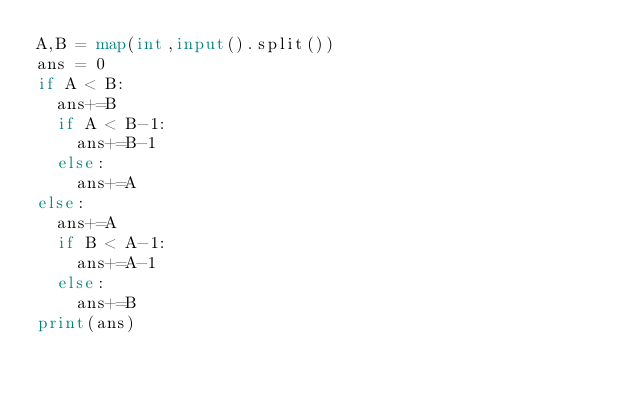Convert code to text. <code><loc_0><loc_0><loc_500><loc_500><_Python_>A,B = map(int,input().split())
ans = 0
if A < B:
  ans+=B
  if A < B-1:
    ans+=B-1
  else:
    ans+=A
else:
  ans+=A
  if B < A-1:
    ans+=A-1
  else:
    ans+=B
print(ans)</code> 